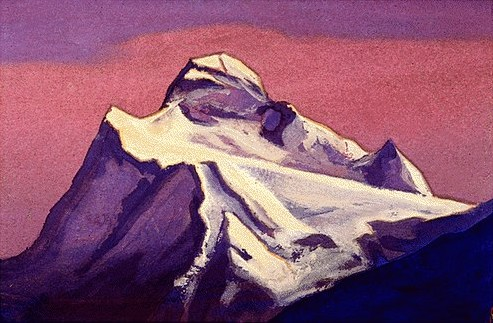Can you describe the mood conveyed by this painting? The mood conveyed by this painting is one of tranquility and awe. The soft, dreamy colors of the sky contrast with the stark, rugged features of the mountain, creating a serene yet majestic ambiance. The gentle blending of pinks and purples in the sky suggests a calm, almost meditative moment, possibly dawn or dusk, while the mountain itself stands as a timeless sentinel of nature's grandeur. What could have inspired the artist to create this piece? The artist may have been inspired by the sheer beauty and majesty of mountains, perhaps drawing from personal experiences or a deep appreciation for natural landscapes. The vibrant colors and dramatic lighting hint at a profound moment of connection with nature, possibly during a memorable sunrise or sunset. This piece could also be an exploration of the interplay between light and shadow, capturing the fleeting moments of ephemerality in the natural world. Can you imagine a story that might be set in this scene? In a distant, mystical land where the veil between the realms of reality and dreams is thin, a small village nestles at the foot of this awe-inspiring mountain. The villagers, guardians of ancient secrets, speak of a legendary phoenix that makes its home at the mountain’s peak. Each year, during the week of the equinox, the sky is painted with these mesmerizing purples and pinks, heralding the fleeting appearance of the phoenix. The elders recount how daring adventurers, drawn by the promise of witnessing the phoenix's rebirth, embark on strenuous ascents, guided only by the ethereal light and the whispers of the mountain winds. For those who succeed are said to be granted visions that transcend ordinary human comprehension, revealing truths about life and the universe. 